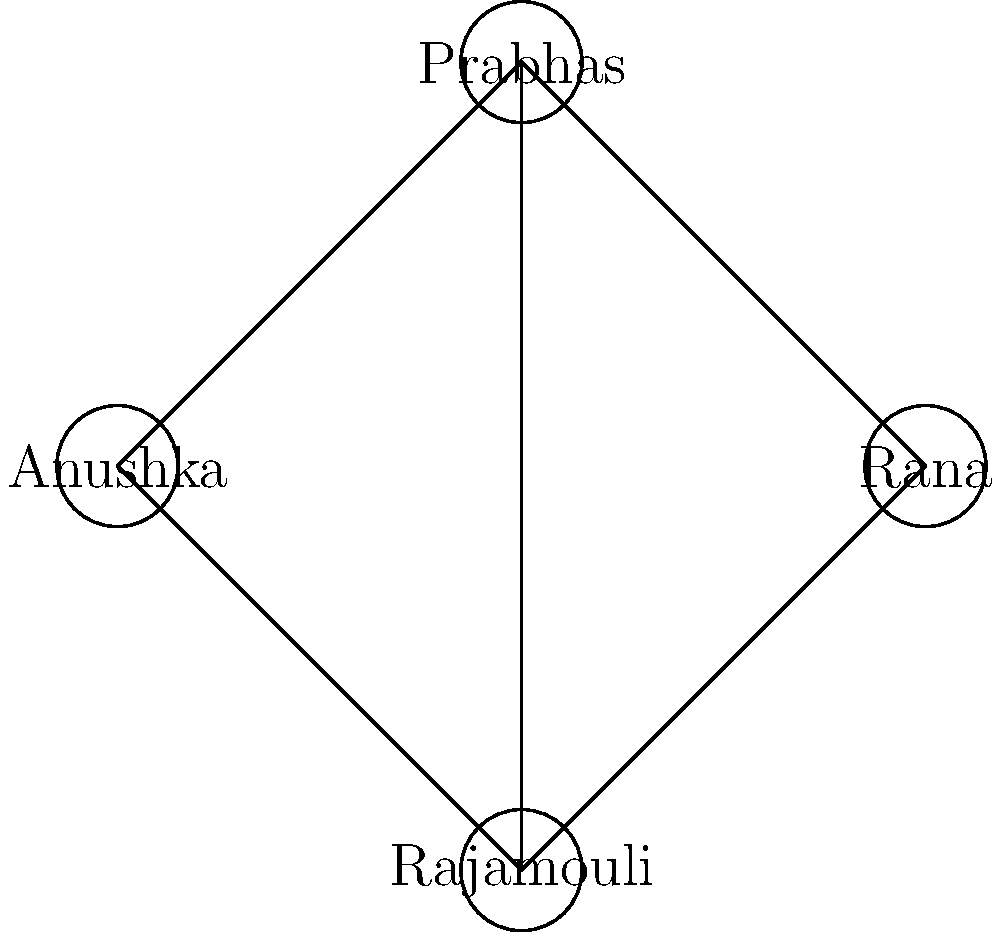In the network graph representing actor collaborations in Telugu cinema, which actor has the highest degree centrality (most connections), and what does this reveal about the industry's tendency to rely on established collaborations? To answer this question, we need to follow these steps:

1. Understand degree centrality: In network analysis, degree centrality is the number of direct connections a node has.

2. Analyze the graph:
   - Prabhas has 3 connections (to Anushka, Rana, and Rajamouli)
   - Anushka has 2 connections (to Prabhas and Rajamouli)
   - Rana has 2 connections (to Prabhas and Rajamouli)
   - Rajamouli has 3 connections (to Prabhas, Anushka, and Rana)

3. Identify the highest degree centrality:
   Both Prabhas and Rajamouli have the highest degree centrality with 3 connections each.

4. Interpret the results:
   The high degree centrality of both an actor (Prabhas) and a director (Rajamouli) reveals that Telugu cinema often relies on established collaborations. This tendency can lead to:
   - Repetitive casting choices
   - Limited opportunities for new talent
   - Potential for creative stagnation due to familiarity

5. Industry implications:
   This reliance on established collaborations contributes to the overused tropes and lazy storytelling that frustrate discerning viewers, as it can result in predictable pairings and storylines.
Answer: Prabhas and Rajamouli (tied); reveals industry's overreliance on established collaborations. 